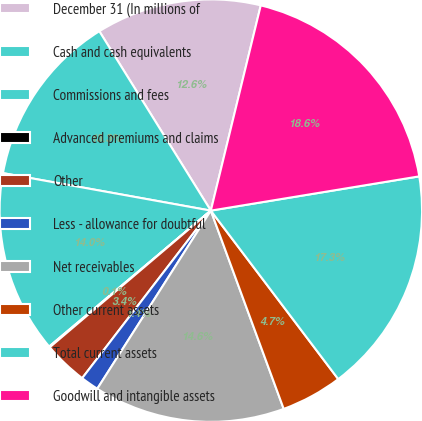<chart> <loc_0><loc_0><loc_500><loc_500><pie_chart><fcel>December 31 (In millions of<fcel>Cash and cash equivalents<fcel>Commissions and fees<fcel>Advanced premiums and claims<fcel>Other<fcel>Less - allowance for doubtful<fcel>Net receivables<fcel>Other current assets<fcel>Total current assets<fcel>Goodwill and intangible assets<nl><fcel>12.65%<fcel>13.31%<fcel>13.97%<fcel>0.07%<fcel>3.38%<fcel>1.39%<fcel>14.64%<fcel>4.7%<fcel>17.29%<fcel>18.61%<nl></chart> 